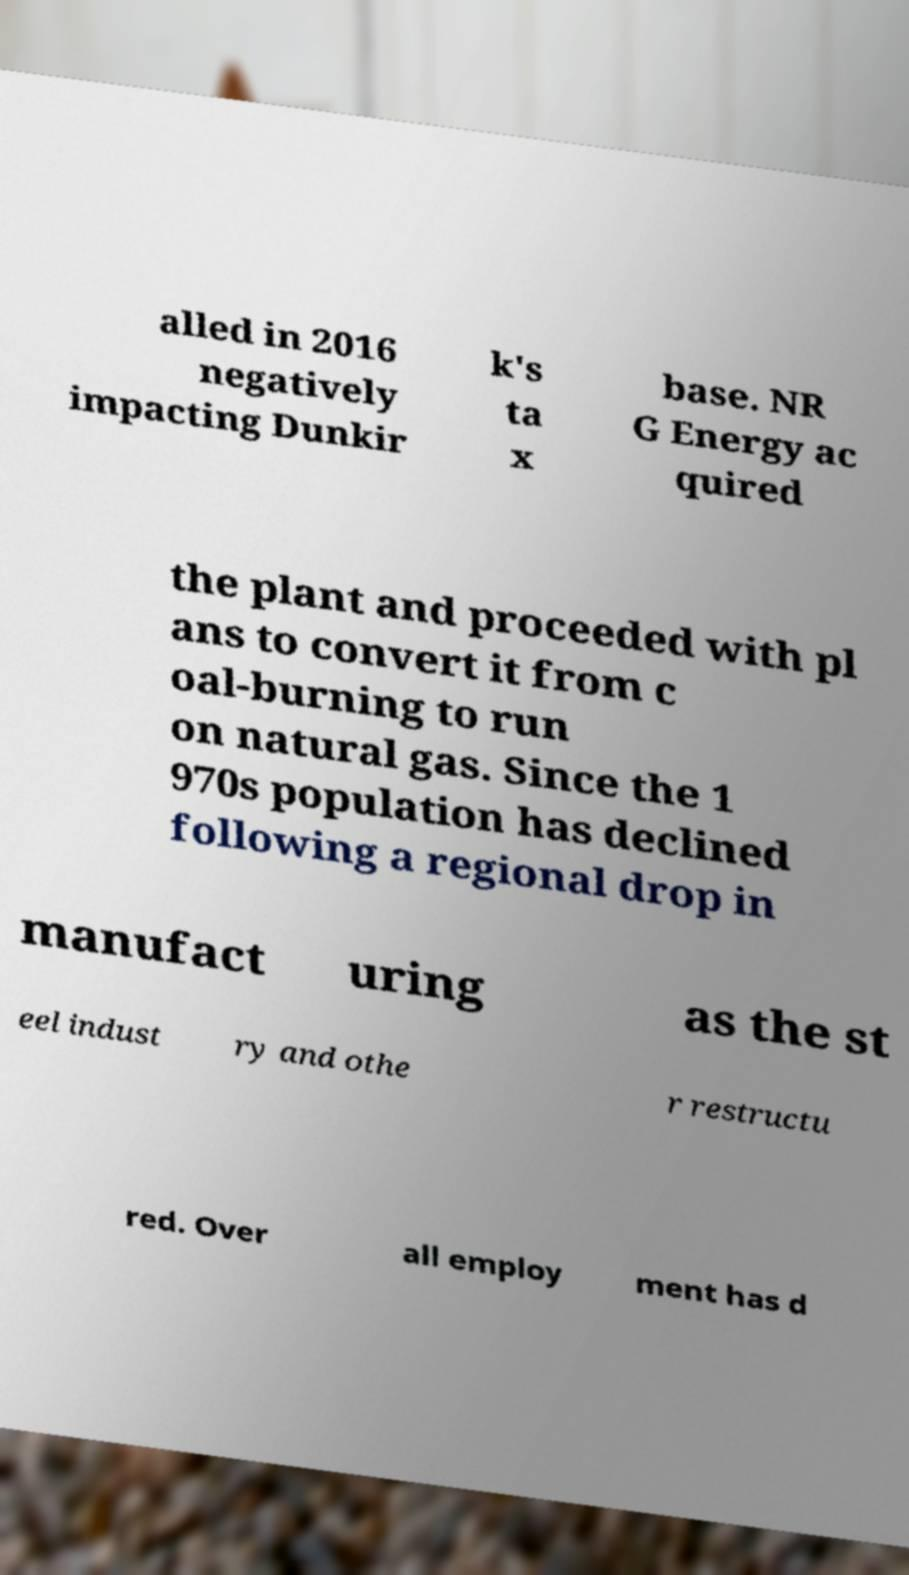What messages or text are displayed in this image? I need them in a readable, typed format. alled in 2016 negatively impacting Dunkir k's ta x base. NR G Energy ac quired the plant and proceeded with pl ans to convert it from c oal-burning to run on natural gas. Since the 1 970s population has declined following a regional drop in manufact uring as the st eel indust ry and othe r restructu red. Over all employ ment has d 